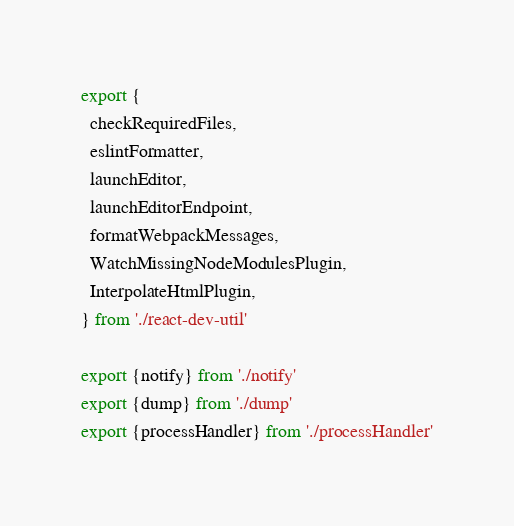Convert code to text. <code><loc_0><loc_0><loc_500><loc_500><_TypeScript_>export {
  checkRequiredFiles,
  eslintFormatter,
  launchEditor,
  launchEditorEndpoint,
  formatWebpackMessages,
  WatchMissingNodeModulesPlugin,
  InterpolateHtmlPlugin,
} from './react-dev-util'

export {notify} from './notify'
export {dump} from './dump'
export {processHandler} from './processHandler'
</code> 